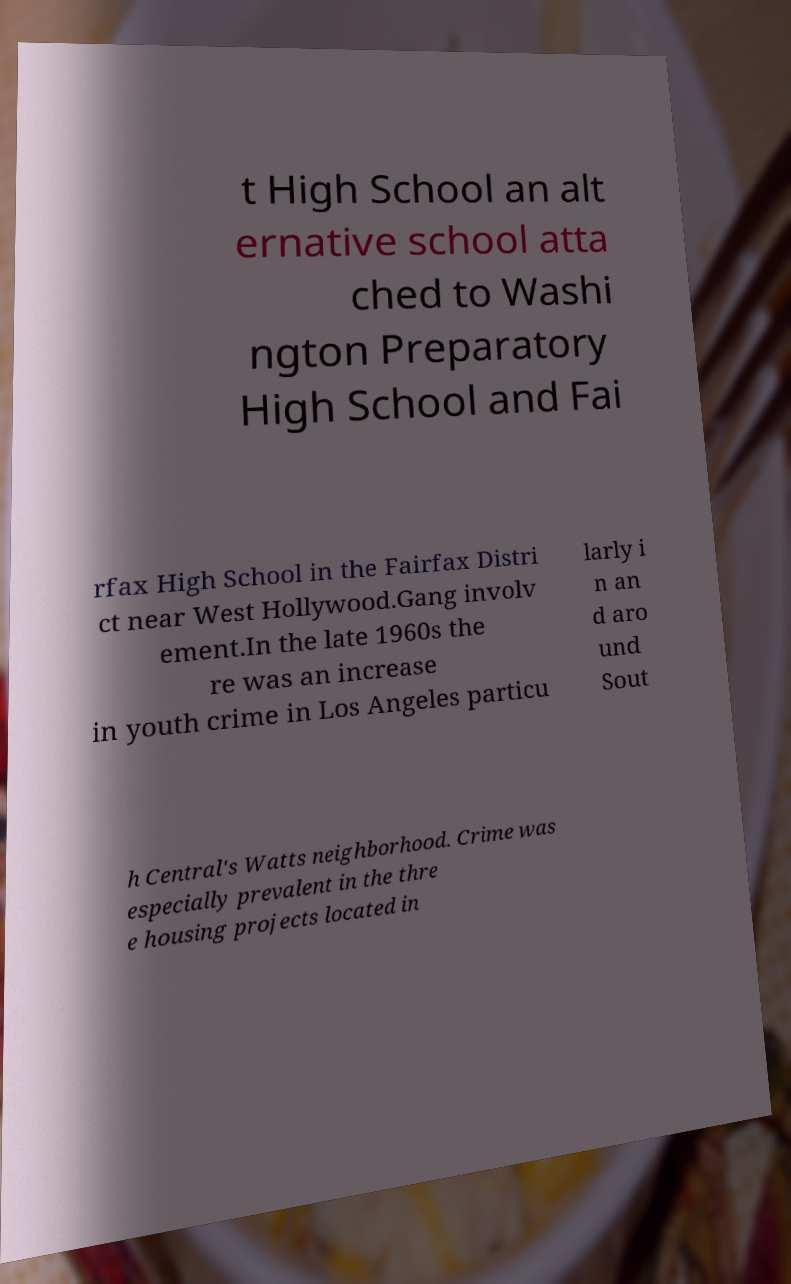There's text embedded in this image that I need extracted. Can you transcribe it verbatim? t High School an alt ernative school atta ched to Washi ngton Preparatory High School and Fai rfax High School in the Fairfax Distri ct near West Hollywood.Gang involv ement.In the late 1960s the re was an increase in youth crime in Los Angeles particu larly i n an d aro und Sout h Central's Watts neighborhood. Crime was especially prevalent in the thre e housing projects located in 